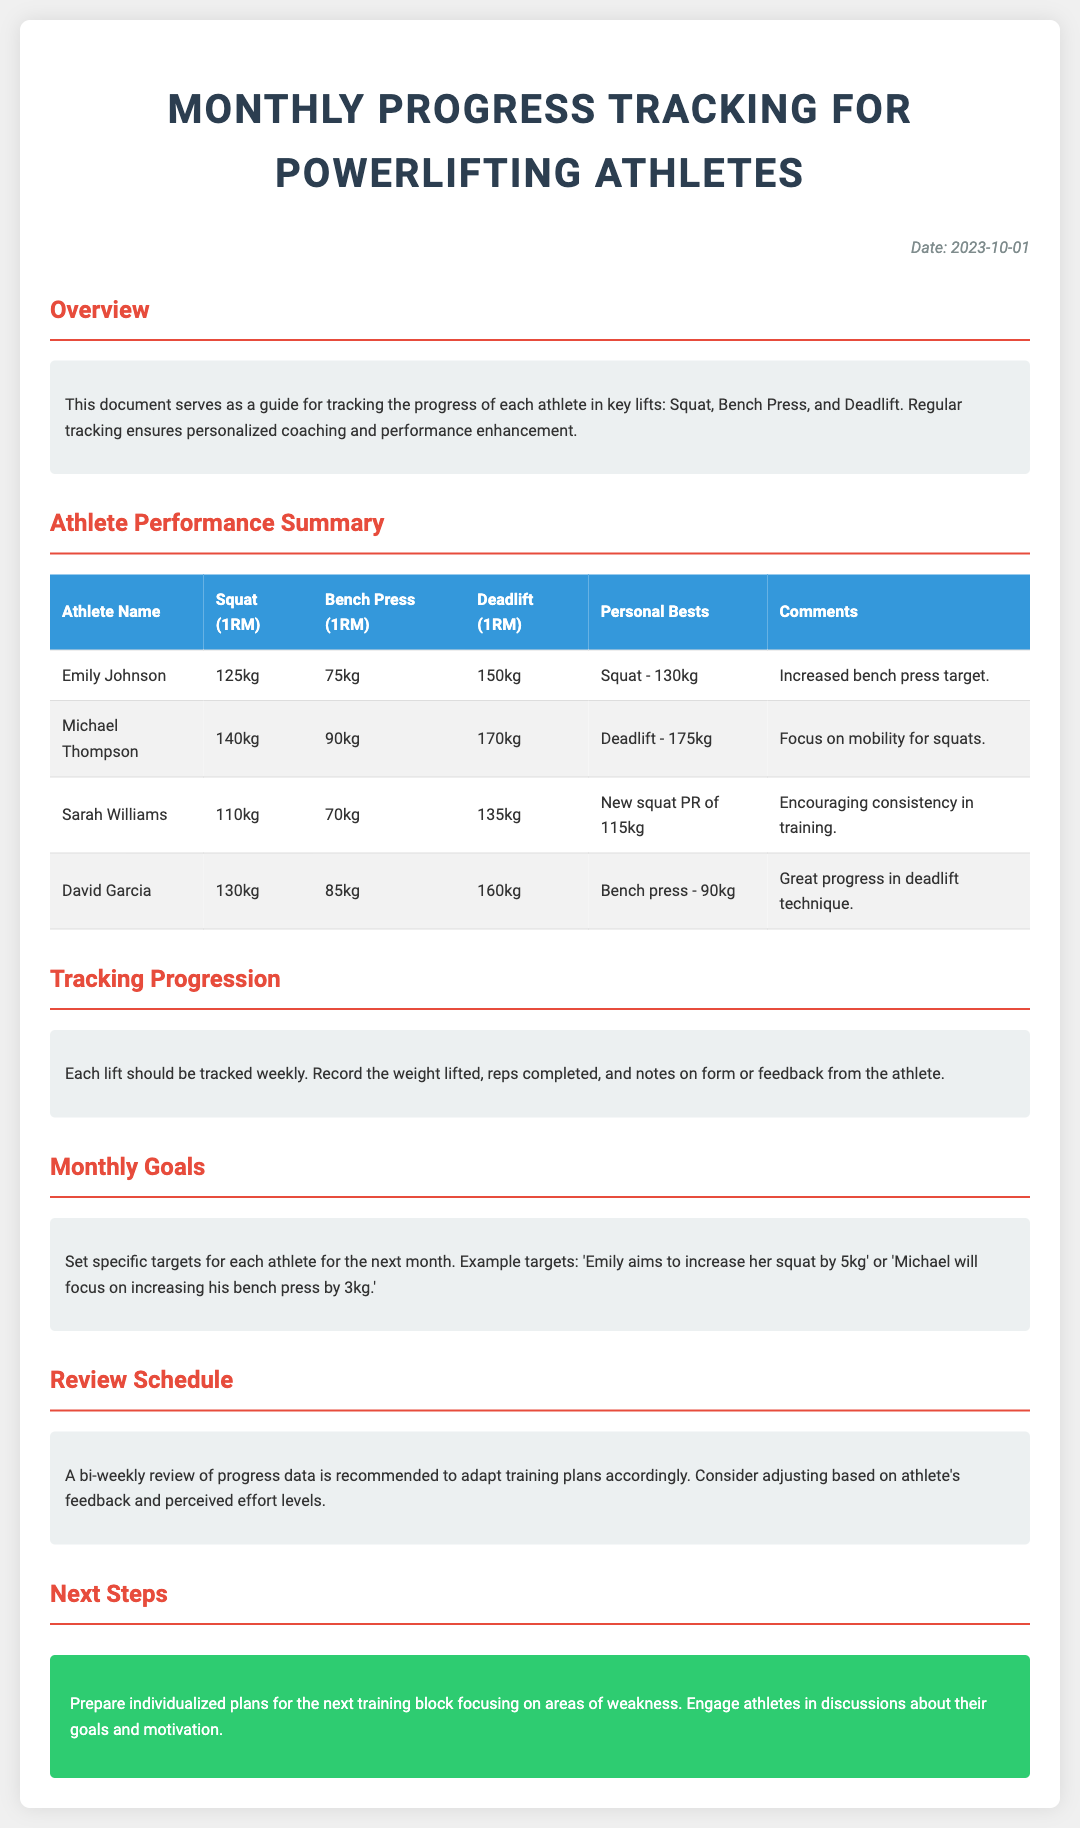What is the title of the document? The title is displayed at the top of the document in a large font.
Answer: Monthly Progress Tracking for Powerlifting Athletes What is Emily Johnson's squat 1RM? The squat 1RM for Emily Johnson is found in the athlete performance summary table.
Answer: 125kg What personal best did Michael Thompson achieve? The personal bests for each athlete are listed in the performance summary table.
Answer: Deadlift - 175kg What is the date of this progress tracking document? The date is mentioned at the top right of the document.
Answer: 2023-10-01 What is the recommended review schedule? The document mentions a suggested frequency for reviews in the review schedule section.
Answer: Bi-weekly review What lift does Sarah Williams have a new PR in? The document states her new PR in the athlete performance summary section.
Answer: Squat What is the goal for Emily Johnson for the next month? The document suggests specific targets for athletes in the monthly goals section.
Answer: Increase her squat by 5kg What is the main purpose of tracking progression? The purpose is mentioned in the section that describes the reasoning behind weekly tracking.
Answer: Personalized coaching and performance enhancement What is a key focus for Michael Thompson according to the comments? Comments are provided in the performance summary table, indicating areas for improvement.
Answer: Mobility for squats 